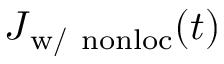<formula> <loc_0><loc_0><loc_500><loc_500>\boldsymbol J _ { w / n o n l o c } ( t )</formula> 